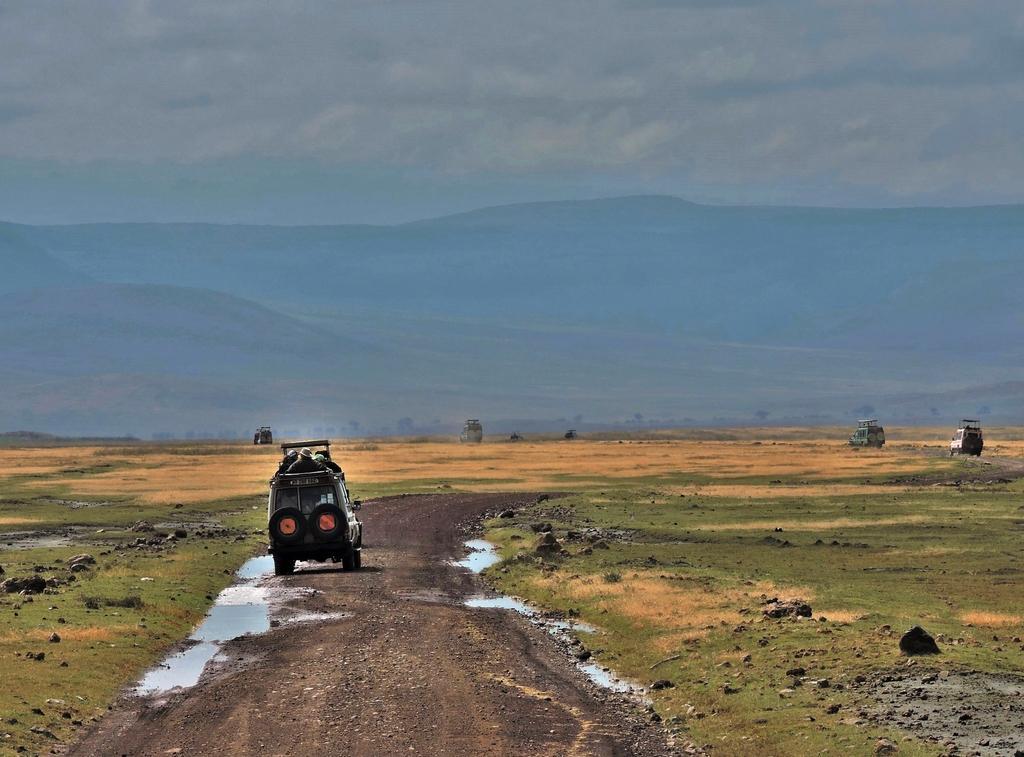Could you give a brief overview of what you see in this image? In this picture I can see vehicles on the road. In the background I can see mountains and the sky. Here I can see grass and water. 